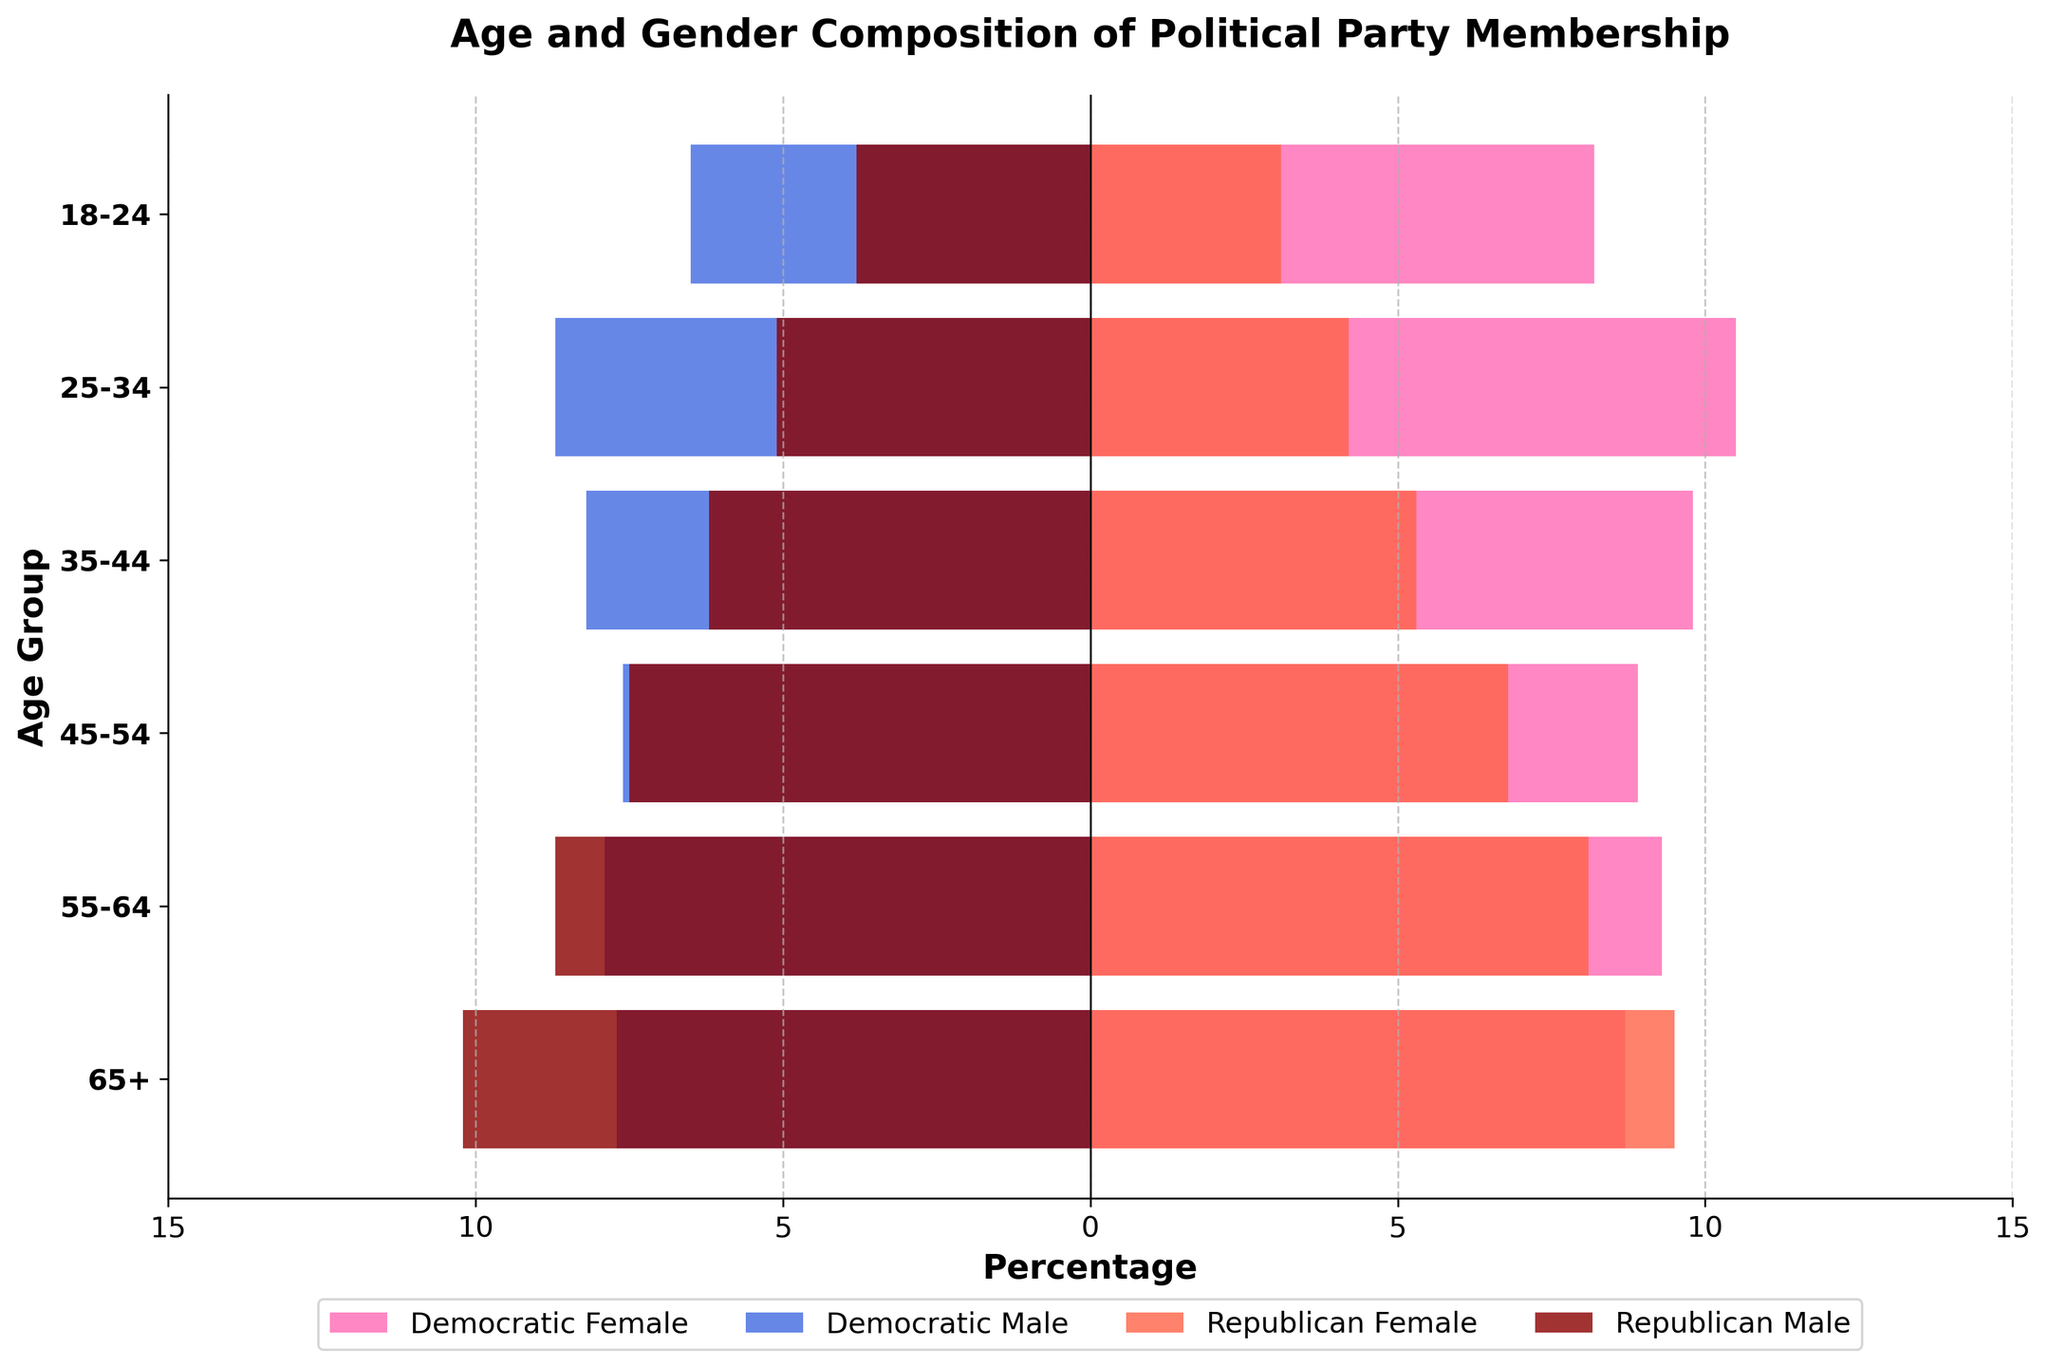What is the title of the figure? The title of the figure is located at the top and provides an overview of what the chart represents. Here, it states "Age and Gender Composition of Political Party Membership."
Answer: Age and Gender Composition of Political Party Membership What age group has the highest percentage of Democratic Party female members? By looking at the pink bars to the right of the zero mark, you can evaluate that the "25-34" age group has the longest bar in Democratic Female members.
Answer: 25-34 Which gender has a higher percentage in the 65+ age group for the Republican Party? Look at the red and dark red bars corresponding to the "65+" age group. The dark red bar (Republican Male) is longer than the red bar (Republican Female).
Answer: Male What is the difference in the percentage of Democratic female members between the 25-34 and 45-54 age groups? Identify the pink bars at the "25-34" and "45-54" age groups. The values are 10.5% and 8.9% respectively. Subtract 8.9 from 10.5 (10.5 - 8.9).
Answer: 1.6% In which age group do males constitute a higher percentage than females for both political parties? Compare the blue and pink bars for the Democratic Party, and the dark red and red bars for the Republican Party within each age group. For both parties, the "65+" age group has higher percentages for males than females.
Answer: 65+ What is the total percentage of Republican members in the 55-64 age group? Sum the percentages of both genders in the "55-64" age group for the Republican Party: 8.1% (Female) + 8.7% (Male).
Answer: 16.8% How does the percentage of Democratic Party females in the 18-24 age group compare to that of Republican Party males in the 45-54 age group? The percentage of Democratic Party females in the "18-24" age group is 8.2%. The percentage of Republican Party males in the "45-54" age group is 7.5%. Compare these two values (8.2 vs. 7.5).
Answer: Higher Which age group shows the least gender disparity within the Democratic Party? Examine the blue and pink bars for each age group to see where the lengths (i.e., percentages) are most similar. The "55-64" age group shows the least disparity, with values of 9.3% (Female) and 7.9% (Male).
Answer: 55-64 What is the average percentage of Democratic Party female members across all age groups? Sum the percentages of Democratic Party females across all age groups: 8.2 + 10.5 + 9.8 + 8.9 + 9.3 + 8.7 = 55.4%. Then divide by the number of age groups (6). 55.4 / 6.
Answer: 9.23% Is there any age group where the combined percentage of Democratic members is equal to the combined percentage of Republican members? Calculate the combined percentages (sum of male and female) for both Democratic and Republican members for each age group. Check for equality. There is no age group where the precise equality exists.
Answer: No 